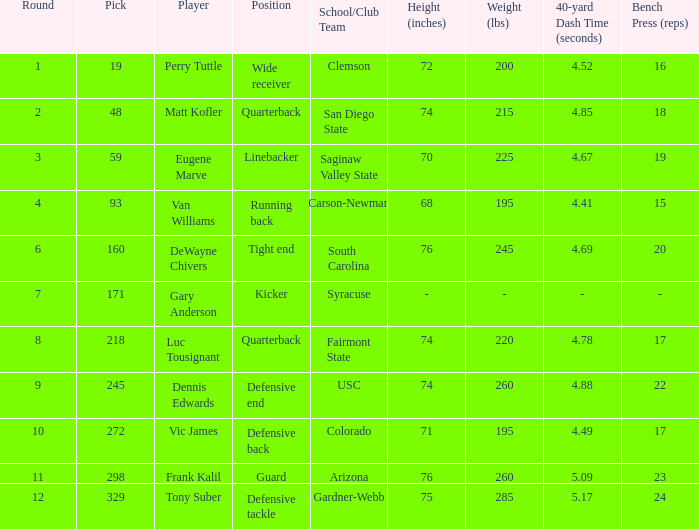Which Round has a School/Club Team of arizona, and a Pick smaller than 298? None. 